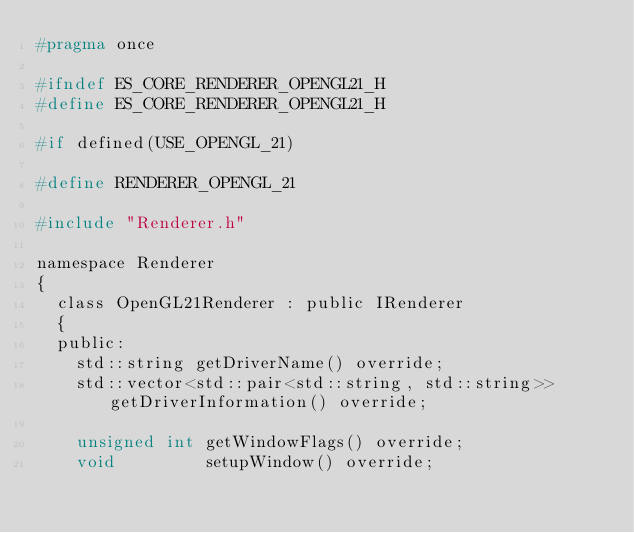<code> <loc_0><loc_0><loc_500><loc_500><_C_>#pragma once

#ifndef ES_CORE_RENDERER_OPENGL21_H
#define ES_CORE_RENDERER_OPENGL21_H

#if defined(USE_OPENGL_21)

#define RENDERER_OPENGL_21

#include "Renderer.h"

namespace Renderer
{
	class OpenGL21Renderer : public IRenderer
	{
	public:
		std::string getDriverName() override;
		std::vector<std::pair<std::string, std::string>> getDriverInformation() override;

		unsigned int getWindowFlags() override;
		void         setupWindow() override;
</code> 